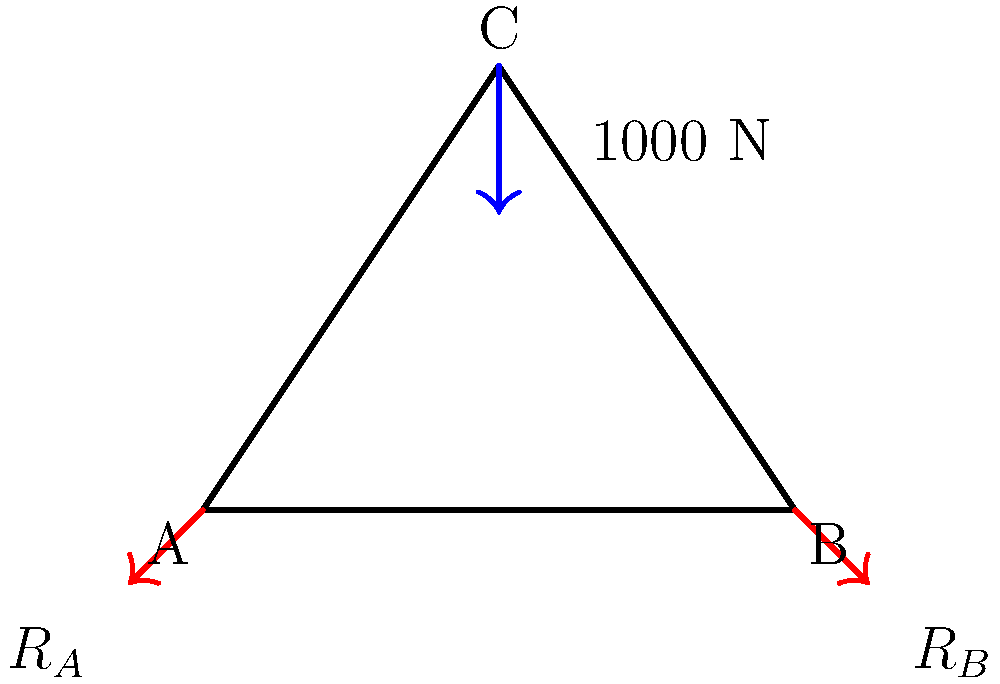In the simple truss structure shown above, a vertical force of 1000 N is applied at point C. Calculate the magnitudes of the reaction forces $R_A$ and $R_B$ at supports A and B, respectively. To solve this problem, we'll use the method of joints and the concept of static equilibrium. Here's a step-by-step approach:

1. Identify the known information:
   - The structure is symmetric
   - A 1000 N force is applied vertically at point C
   - The span of the truss (distance AB) is 4 units
   - The height of the truss (vertical distance from AB to C) is 3 units

2. Apply the equations of static equilibrium:
   $$\sum F_x = 0$$
   $$\sum F_y = 0$$
   $$\sum M_A = 0$$ (taking moments about point A)

3. From symmetry, we can deduce that $R_A = R_B$ due to the symmetric loading and geometry.

4. Using $\sum F_y = 0$:
   $$R_A + R_B - 1000 = 0$$
   $$2R_A - 1000 = 0$$ (since $R_A = R_B$)
   $$R_A = 500 \text{ N}$$

5. To verify, let's use the moment equation $\sum M_A = 0$:
   $$1000 \cdot 2 - R_B \cdot 4 = 0$$
   $$2000 - 4R_B = 0$$
   $$R_B = 500 \text{ N}$$

This confirms our result from step 4.
Answer: $R_A = R_B = 500 \text{ N}$ 